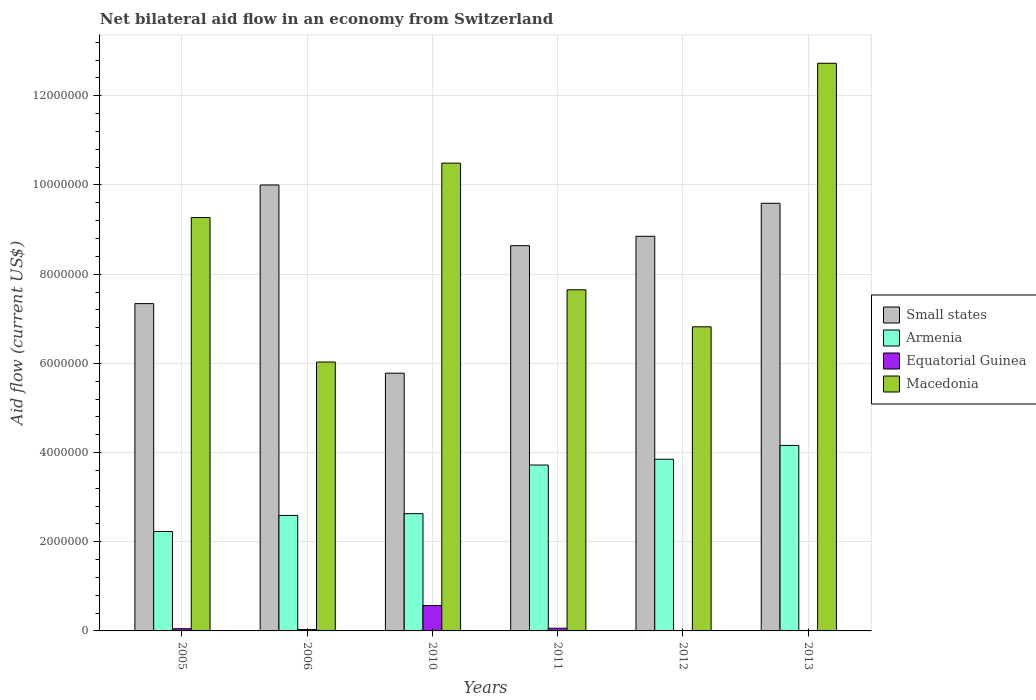How many different coloured bars are there?
Your answer should be very brief. 4. How many groups of bars are there?
Your response must be concise. 6. Are the number of bars on each tick of the X-axis equal?
Give a very brief answer. Yes. What is the label of the 5th group of bars from the left?
Provide a short and direct response. 2012. In how many cases, is the number of bars for a given year not equal to the number of legend labels?
Give a very brief answer. 0. What is the net bilateral aid flow in Armenia in 2010?
Your response must be concise. 2.63e+06. Across all years, what is the maximum net bilateral aid flow in Armenia?
Your response must be concise. 4.16e+06. Across all years, what is the minimum net bilateral aid flow in Equatorial Guinea?
Give a very brief answer. 10000. In which year was the net bilateral aid flow in Small states maximum?
Keep it short and to the point. 2006. What is the total net bilateral aid flow in Macedonia in the graph?
Your answer should be compact. 5.30e+07. What is the difference between the net bilateral aid flow in Small states in 2012 and the net bilateral aid flow in Macedonia in 2006?
Provide a succinct answer. 2.82e+06. What is the average net bilateral aid flow in Armenia per year?
Ensure brevity in your answer.  3.20e+06. In the year 2010, what is the difference between the net bilateral aid flow in Small states and net bilateral aid flow in Armenia?
Give a very brief answer. 3.15e+06. In how many years, is the net bilateral aid flow in Equatorial Guinea greater than 1200000 US$?
Ensure brevity in your answer.  0. What is the ratio of the net bilateral aid flow in Equatorial Guinea in 2005 to that in 2010?
Your response must be concise. 0.09. Is the difference between the net bilateral aid flow in Small states in 2011 and 2012 greater than the difference between the net bilateral aid flow in Armenia in 2011 and 2012?
Provide a short and direct response. No. What is the difference between the highest and the second highest net bilateral aid flow in Armenia?
Offer a terse response. 3.10e+05. What is the difference between the highest and the lowest net bilateral aid flow in Small states?
Your answer should be very brief. 4.22e+06. Is the sum of the net bilateral aid flow in Macedonia in 2011 and 2013 greater than the maximum net bilateral aid flow in Armenia across all years?
Provide a succinct answer. Yes. What does the 3rd bar from the left in 2005 represents?
Give a very brief answer. Equatorial Guinea. What does the 3rd bar from the right in 2005 represents?
Provide a short and direct response. Armenia. Is it the case that in every year, the sum of the net bilateral aid flow in Equatorial Guinea and net bilateral aid flow in Small states is greater than the net bilateral aid flow in Armenia?
Your answer should be very brief. Yes. How many bars are there?
Provide a short and direct response. 24. What is the difference between two consecutive major ticks on the Y-axis?
Give a very brief answer. 2.00e+06. Are the values on the major ticks of Y-axis written in scientific E-notation?
Your answer should be compact. No. Does the graph contain any zero values?
Offer a very short reply. No. Does the graph contain grids?
Provide a short and direct response. Yes. Where does the legend appear in the graph?
Provide a short and direct response. Center right. What is the title of the graph?
Ensure brevity in your answer.  Net bilateral aid flow in an economy from Switzerland. Does "Hungary" appear as one of the legend labels in the graph?
Your response must be concise. No. What is the label or title of the X-axis?
Make the answer very short. Years. What is the label or title of the Y-axis?
Your answer should be compact. Aid flow (current US$). What is the Aid flow (current US$) of Small states in 2005?
Your answer should be compact. 7.34e+06. What is the Aid flow (current US$) in Armenia in 2005?
Your answer should be compact. 2.23e+06. What is the Aid flow (current US$) in Macedonia in 2005?
Your answer should be compact. 9.27e+06. What is the Aid flow (current US$) of Armenia in 2006?
Provide a short and direct response. 2.59e+06. What is the Aid flow (current US$) in Macedonia in 2006?
Offer a terse response. 6.03e+06. What is the Aid flow (current US$) of Small states in 2010?
Give a very brief answer. 5.78e+06. What is the Aid flow (current US$) in Armenia in 2010?
Your answer should be very brief. 2.63e+06. What is the Aid flow (current US$) in Equatorial Guinea in 2010?
Offer a terse response. 5.70e+05. What is the Aid flow (current US$) in Macedonia in 2010?
Keep it short and to the point. 1.05e+07. What is the Aid flow (current US$) in Small states in 2011?
Your answer should be very brief. 8.64e+06. What is the Aid flow (current US$) in Armenia in 2011?
Keep it short and to the point. 3.72e+06. What is the Aid flow (current US$) in Macedonia in 2011?
Provide a short and direct response. 7.65e+06. What is the Aid flow (current US$) of Small states in 2012?
Keep it short and to the point. 8.85e+06. What is the Aid flow (current US$) in Armenia in 2012?
Offer a terse response. 3.85e+06. What is the Aid flow (current US$) in Macedonia in 2012?
Offer a terse response. 6.82e+06. What is the Aid flow (current US$) of Small states in 2013?
Provide a succinct answer. 9.59e+06. What is the Aid flow (current US$) of Armenia in 2013?
Provide a short and direct response. 4.16e+06. What is the Aid flow (current US$) of Macedonia in 2013?
Offer a terse response. 1.27e+07. Across all years, what is the maximum Aid flow (current US$) in Small states?
Offer a terse response. 1.00e+07. Across all years, what is the maximum Aid flow (current US$) in Armenia?
Give a very brief answer. 4.16e+06. Across all years, what is the maximum Aid flow (current US$) in Equatorial Guinea?
Your response must be concise. 5.70e+05. Across all years, what is the maximum Aid flow (current US$) in Macedonia?
Your answer should be compact. 1.27e+07. Across all years, what is the minimum Aid flow (current US$) in Small states?
Provide a succinct answer. 5.78e+06. Across all years, what is the minimum Aid flow (current US$) in Armenia?
Keep it short and to the point. 2.23e+06. Across all years, what is the minimum Aid flow (current US$) in Macedonia?
Your answer should be compact. 6.03e+06. What is the total Aid flow (current US$) of Small states in the graph?
Keep it short and to the point. 5.02e+07. What is the total Aid flow (current US$) of Armenia in the graph?
Offer a terse response. 1.92e+07. What is the total Aid flow (current US$) in Equatorial Guinea in the graph?
Provide a succinct answer. 7.30e+05. What is the total Aid flow (current US$) in Macedonia in the graph?
Offer a terse response. 5.30e+07. What is the difference between the Aid flow (current US$) in Small states in 2005 and that in 2006?
Your answer should be very brief. -2.66e+06. What is the difference between the Aid flow (current US$) in Armenia in 2005 and that in 2006?
Your answer should be compact. -3.60e+05. What is the difference between the Aid flow (current US$) in Equatorial Guinea in 2005 and that in 2006?
Offer a terse response. 2.00e+04. What is the difference between the Aid flow (current US$) in Macedonia in 2005 and that in 2006?
Offer a very short reply. 3.24e+06. What is the difference between the Aid flow (current US$) of Small states in 2005 and that in 2010?
Offer a very short reply. 1.56e+06. What is the difference between the Aid flow (current US$) of Armenia in 2005 and that in 2010?
Keep it short and to the point. -4.00e+05. What is the difference between the Aid flow (current US$) of Equatorial Guinea in 2005 and that in 2010?
Keep it short and to the point. -5.20e+05. What is the difference between the Aid flow (current US$) of Macedonia in 2005 and that in 2010?
Your answer should be compact. -1.22e+06. What is the difference between the Aid flow (current US$) in Small states in 2005 and that in 2011?
Offer a terse response. -1.30e+06. What is the difference between the Aid flow (current US$) in Armenia in 2005 and that in 2011?
Make the answer very short. -1.49e+06. What is the difference between the Aid flow (current US$) of Equatorial Guinea in 2005 and that in 2011?
Offer a terse response. -10000. What is the difference between the Aid flow (current US$) of Macedonia in 2005 and that in 2011?
Make the answer very short. 1.62e+06. What is the difference between the Aid flow (current US$) of Small states in 2005 and that in 2012?
Offer a very short reply. -1.51e+06. What is the difference between the Aid flow (current US$) of Armenia in 2005 and that in 2012?
Provide a succinct answer. -1.62e+06. What is the difference between the Aid flow (current US$) of Equatorial Guinea in 2005 and that in 2012?
Ensure brevity in your answer.  4.00e+04. What is the difference between the Aid flow (current US$) of Macedonia in 2005 and that in 2012?
Provide a succinct answer. 2.45e+06. What is the difference between the Aid flow (current US$) of Small states in 2005 and that in 2013?
Give a very brief answer. -2.25e+06. What is the difference between the Aid flow (current US$) of Armenia in 2005 and that in 2013?
Ensure brevity in your answer.  -1.93e+06. What is the difference between the Aid flow (current US$) in Equatorial Guinea in 2005 and that in 2013?
Keep it short and to the point. 4.00e+04. What is the difference between the Aid flow (current US$) of Macedonia in 2005 and that in 2013?
Your answer should be very brief. -3.46e+06. What is the difference between the Aid flow (current US$) in Small states in 2006 and that in 2010?
Keep it short and to the point. 4.22e+06. What is the difference between the Aid flow (current US$) of Armenia in 2006 and that in 2010?
Offer a terse response. -4.00e+04. What is the difference between the Aid flow (current US$) of Equatorial Guinea in 2006 and that in 2010?
Give a very brief answer. -5.40e+05. What is the difference between the Aid flow (current US$) in Macedonia in 2006 and that in 2010?
Provide a succinct answer. -4.46e+06. What is the difference between the Aid flow (current US$) in Small states in 2006 and that in 2011?
Ensure brevity in your answer.  1.36e+06. What is the difference between the Aid flow (current US$) in Armenia in 2006 and that in 2011?
Your answer should be compact. -1.13e+06. What is the difference between the Aid flow (current US$) in Equatorial Guinea in 2006 and that in 2011?
Make the answer very short. -3.00e+04. What is the difference between the Aid flow (current US$) of Macedonia in 2006 and that in 2011?
Offer a terse response. -1.62e+06. What is the difference between the Aid flow (current US$) of Small states in 2006 and that in 2012?
Make the answer very short. 1.15e+06. What is the difference between the Aid flow (current US$) of Armenia in 2006 and that in 2012?
Your response must be concise. -1.26e+06. What is the difference between the Aid flow (current US$) in Macedonia in 2006 and that in 2012?
Your response must be concise. -7.90e+05. What is the difference between the Aid flow (current US$) in Armenia in 2006 and that in 2013?
Keep it short and to the point. -1.57e+06. What is the difference between the Aid flow (current US$) in Equatorial Guinea in 2006 and that in 2013?
Keep it short and to the point. 2.00e+04. What is the difference between the Aid flow (current US$) in Macedonia in 2006 and that in 2013?
Give a very brief answer. -6.70e+06. What is the difference between the Aid flow (current US$) of Small states in 2010 and that in 2011?
Your response must be concise. -2.86e+06. What is the difference between the Aid flow (current US$) of Armenia in 2010 and that in 2011?
Your response must be concise. -1.09e+06. What is the difference between the Aid flow (current US$) of Equatorial Guinea in 2010 and that in 2011?
Give a very brief answer. 5.10e+05. What is the difference between the Aid flow (current US$) in Macedonia in 2010 and that in 2011?
Provide a succinct answer. 2.84e+06. What is the difference between the Aid flow (current US$) in Small states in 2010 and that in 2012?
Offer a terse response. -3.07e+06. What is the difference between the Aid flow (current US$) of Armenia in 2010 and that in 2012?
Provide a succinct answer. -1.22e+06. What is the difference between the Aid flow (current US$) in Equatorial Guinea in 2010 and that in 2012?
Offer a very short reply. 5.60e+05. What is the difference between the Aid flow (current US$) of Macedonia in 2010 and that in 2012?
Your answer should be very brief. 3.67e+06. What is the difference between the Aid flow (current US$) in Small states in 2010 and that in 2013?
Give a very brief answer. -3.81e+06. What is the difference between the Aid flow (current US$) in Armenia in 2010 and that in 2013?
Offer a very short reply. -1.53e+06. What is the difference between the Aid flow (current US$) of Equatorial Guinea in 2010 and that in 2013?
Your answer should be very brief. 5.60e+05. What is the difference between the Aid flow (current US$) in Macedonia in 2010 and that in 2013?
Offer a very short reply. -2.24e+06. What is the difference between the Aid flow (current US$) in Armenia in 2011 and that in 2012?
Give a very brief answer. -1.30e+05. What is the difference between the Aid flow (current US$) in Equatorial Guinea in 2011 and that in 2012?
Make the answer very short. 5.00e+04. What is the difference between the Aid flow (current US$) in Macedonia in 2011 and that in 2012?
Provide a succinct answer. 8.30e+05. What is the difference between the Aid flow (current US$) of Small states in 2011 and that in 2013?
Offer a terse response. -9.50e+05. What is the difference between the Aid flow (current US$) in Armenia in 2011 and that in 2013?
Make the answer very short. -4.40e+05. What is the difference between the Aid flow (current US$) of Macedonia in 2011 and that in 2013?
Offer a very short reply. -5.08e+06. What is the difference between the Aid flow (current US$) in Small states in 2012 and that in 2013?
Your answer should be compact. -7.40e+05. What is the difference between the Aid flow (current US$) in Armenia in 2012 and that in 2013?
Your answer should be very brief. -3.10e+05. What is the difference between the Aid flow (current US$) in Equatorial Guinea in 2012 and that in 2013?
Your answer should be compact. 0. What is the difference between the Aid flow (current US$) in Macedonia in 2012 and that in 2013?
Offer a terse response. -5.91e+06. What is the difference between the Aid flow (current US$) in Small states in 2005 and the Aid flow (current US$) in Armenia in 2006?
Your response must be concise. 4.75e+06. What is the difference between the Aid flow (current US$) of Small states in 2005 and the Aid flow (current US$) of Equatorial Guinea in 2006?
Your response must be concise. 7.31e+06. What is the difference between the Aid flow (current US$) of Small states in 2005 and the Aid flow (current US$) of Macedonia in 2006?
Give a very brief answer. 1.31e+06. What is the difference between the Aid flow (current US$) in Armenia in 2005 and the Aid flow (current US$) in Equatorial Guinea in 2006?
Offer a terse response. 2.20e+06. What is the difference between the Aid flow (current US$) in Armenia in 2005 and the Aid flow (current US$) in Macedonia in 2006?
Your response must be concise. -3.80e+06. What is the difference between the Aid flow (current US$) in Equatorial Guinea in 2005 and the Aid flow (current US$) in Macedonia in 2006?
Provide a short and direct response. -5.98e+06. What is the difference between the Aid flow (current US$) in Small states in 2005 and the Aid flow (current US$) in Armenia in 2010?
Your answer should be very brief. 4.71e+06. What is the difference between the Aid flow (current US$) in Small states in 2005 and the Aid flow (current US$) in Equatorial Guinea in 2010?
Give a very brief answer. 6.77e+06. What is the difference between the Aid flow (current US$) in Small states in 2005 and the Aid flow (current US$) in Macedonia in 2010?
Keep it short and to the point. -3.15e+06. What is the difference between the Aid flow (current US$) of Armenia in 2005 and the Aid flow (current US$) of Equatorial Guinea in 2010?
Keep it short and to the point. 1.66e+06. What is the difference between the Aid flow (current US$) in Armenia in 2005 and the Aid flow (current US$) in Macedonia in 2010?
Your answer should be very brief. -8.26e+06. What is the difference between the Aid flow (current US$) of Equatorial Guinea in 2005 and the Aid flow (current US$) of Macedonia in 2010?
Provide a succinct answer. -1.04e+07. What is the difference between the Aid flow (current US$) of Small states in 2005 and the Aid flow (current US$) of Armenia in 2011?
Your answer should be compact. 3.62e+06. What is the difference between the Aid flow (current US$) in Small states in 2005 and the Aid flow (current US$) in Equatorial Guinea in 2011?
Provide a short and direct response. 7.28e+06. What is the difference between the Aid flow (current US$) in Small states in 2005 and the Aid flow (current US$) in Macedonia in 2011?
Keep it short and to the point. -3.10e+05. What is the difference between the Aid flow (current US$) of Armenia in 2005 and the Aid flow (current US$) of Equatorial Guinea in 2011?
Give a very brief answer. 2.17e+06. What is the difference between the Aid flow (current US$) in Armenia in 2005 and the Aid flow (current US$) in Macedonia in 2011?
Give a very brief answer. -5.42e+06. What is the difference between the Aid flow (current US$) in Equatorial Guinea in 2005 and the Aid flow (current US$) in Macedonia in 2011?
Provide a succinct answer. -7.60e+06. What is the difference between the Aid flow (current US$) of Small states in 2005 and the Aid flow (current US$) of Armenia in 2012?
Provide a short and direct response. 3.49e+06. What is the difference between the Aid flow (current US$) in Small states in 2005 and the Aid flow (current US$) in Equatorial Guinea in 2012?
Ensure brevity in your answer.  7.33e+06. What is the difference between the Aid flow (current US$) of Small states in 2005 and the Aid flow (current US$) of Macedonia in 2012?
Your answer should be compact. 5.20e+05. What is the difference between the Aid flow (current US$) in Armenia in 2005 and the Aid flow (current US$) in Equatorial Guinea in 2012?
Offer a very short reply. 2.22e+06. What is the difference between the Aid flow (current US$) of Armenia in 2005 and the Aid flow (current US$) of Macedonia in 2012?
Offer a terse response. -4.59e+06. What is the difference between the Aid flow (current US$) of Equatorial Guinea in 2005 and the Aid flow (current US$) of Macedonia in 2012?
Keep it short and to the point. -6.77e+06. What is the difference between the Aid flow (current US$) of Small states in 2005 and the Aid flow (current US$) of Armenia in 2013?
Your answer should be very brief. 3.18e+06. What is the difference between the Aid flow (current US$) of Small states in 2005 and the Aid flow (current US$) of Equatorial Guinea in 2013?
Provide a succinct answer. 7.33e+06. What is the difference between the Aid flow (current US$) of Small states in 2005 and the Aid flow (current US$) of Macedonia in 2013?
Your response must be concise. -5.39e+06. What is the difference between the Aid flow (current US$) in Armenia in 2005 and the Aid flow (current US$) in Equatorial Guinea in 2013?
Your answer should be very brief. 2.22e+06. What is the difference between the Aid flow (current US$) of Armenia in 2005 and the Aid flow (current US$) of Macedonia in 2013?
Provide a short and direct response. -1.05e+07. What is the difference between the Aid flow (current US$) of Equatorial Guinea in 2005 and the Aid flow (current US$) of Macedonia in 2013?
Give a very brief answer. -1.27e+07. What is the difference between the Aid flow (current US$) in Small states in 2006 and the Aid flow (current US$) in Armenia in 2010?
Your answer should be compact. 7.37e+06. What is the difference between the Aid flow (current US$) in Small states in 2006 and the Aid flow (current US$) in Equatorial Guinea in 2010?
Give a very brief answer. 9.43e+06. What is the difference between the Aid flow (current US$) in Small states in 2006 and the Aid flow (current US$) in Macedonia in 2010?
Your answer should be compact. -4.90e+05. What is the difference between the Aid flow (current US$) in Armenia in 2006 and the Aid flow (current US$) in Equatorial Guinea in 2010?
Provide a short and direct response. 2.02e+06. What is the difference between the Aid flow (current US$) in Armenia in 2006 and the Aid flow (current US$) in Macedonia in 2010?
Provide a short and direct response. -7.90e+06. What is the difference between the Aid flow (current US$) of Equatorial Guinea in 2006 and the Aid flow (current US$) of Macedonia in 2010?
Ensure brevity in your answer.  -1.05e+07. What is the difference between the Aid flow (current US$) of Small states in 2006 and the Aid flow (current US$) of Armenia in 2011?
Ensure brevity in your answer.  6.28e+06. What is the difference between the Aid flow (current US$) of Small states in 2006 and the Aid flow (current US$) of Equatorial Guinea in 2011?
Your response must be concise. 9.94e+06. What is the difference between the Aid flow (current US$) of Small states in 2006 and the Aid flow (current US$) of Macedonia in 2011?
Your response must be concise. 2.35e+06. What is the difference between the Aid flow (current US$) in Armenia in 2006 and the Aid flow (current US$) in Equatorial Guinea in 2011?
Provide a short and direct response. 2.53e+06. What is the difference between the Aid flow (current US$) of Armenia in 2006 and the Aid flow (current US$) of Macedonia in 2011?
Keep it short and to the point. -5.06e+06. What is the difference between the Aid flow (current US$) of Equatorial Guinea in 2006 and the Aid flow (current US$) of Macedonia in 2011?
Provide a succinct answer. -7.62e+06. What is the difference between the Aid flow (current US$) of Small states in 2006 and the Aid flow (current US$) of Armenia in 2012?
Provide a succinct answer. 6.15e+06. What is the difference between the Aid flow (current US$) in Small states in 2006 and the Aid flow (current US$) in Equatorial Guinea in 2012?
Make the answer very short. 9.99e+06. What is the difference between the Aid flow (current US$) of Small states in 2006 and the Aid flow (current US$) of Macedonia in 2012?
Give a very brief answer. 3.18e+06. What is the difference between the Aid flow (current US$) of Armenia in 2006 and the Aid flow (current US$) of Equatorial Guinea in 2012?
Provide a short and direct response. 2.58e+06. What is the difference between the Aid flow (current US$) of Armenia in 2006 and the Aid flow (current US$) of Macedonia in 2012?
Your answer should be very brief. -4.23e+06. What is the difference between the Aid flow (current US$) in Equatorial Guinea in 2006 and the Aid flow (current US$) in Macedonia in 2012?
Provide a succinct answer. -6.79e+06. What is the difference between the Aid flow (current US$) of Small states in 2006 and the Aid flow (current US$) of Armenia in 2013?
Your response must be concise. 5.84e+06. What is the difference between the Aid flow (current US$) in Small states in 2006 and the Aid flow (current US$) in Equatorial Guinea in 2013?
Ensure brevity in your answer.  9.99e+06. What is the difference between the Aid flow (current US$) of Small states in 2006 and the Aid flow (current US$) of Macedonia in 2013?
Your answer should be very brief. -2.73e+06. What is the difference between the Aid flow (current US$) of Armenia in 2006 and the Aid flow (current US$) of Equatorial Guinea in 2013?
Your answer should be very brief. 2.58e+06. What is the difference between the Aid flow (current US$) of Armenia in 2006 and the Aid flow (current US$) of Macedonia in 2013?
Your answer should be compact. -1.01e+07. What is the difference between the Aid flow (current US$) of Equatorial Guinea in 2006 and the Aid flow (current US$) of Macedonia in 2013?
Offer a very short reply. -1.27e+07. What is the difference between the Aid flow (current US$) in Small states in 2010 and the Aid flow (current US$) in Armenia in 2011?
Your answer should be compact. 2.06e+06. What is the difference between the Aid flow (current US$) of Small states in 2010 and the Aid flow (current US$) of Equatorial Guinea in 2011?
Offer a terse response. 5.72e+06. What is the difference between the Aid flow (current US$) in Small states in 2010 and the Aid flow (current US$) in Macedonia in 2011?
Give a very brief answer. -1.87e+06. What is the difference between the Aid flow (current US$) in Armenia in 2010 and the Aid flow (current US$) in Equatorial Guinea in 2011?
Offer a very short reply. 2.57e+06. What is the difference between the Aid flow (current US$) of Armenia in 2010 and the Aid flow (current US$) of Macedonia in 2011?
Your answer should be very brief. -5.02e+06. What is the difference between the Aid flow (current US$) of Equatorial Guinea in 2010 and the Aid flow (current US$) of Macedonia in 2011?
Ensure brevity in your answer.  -7.08e+06. What is the difference between the Aid flow (current US$) of Small states in 2010 and the Aid flow (current US$) of Armenia in 2012?
Offer a very short reply. 1.93e+06. What is the difference between the Aid flow (current US$) of Small states in 2010 and the Aid flow (current US$) of Equatorial Guinea in 2012?
Offer a terse response. 5.77e+06. What is the difference between the Aid flow (current US$) of Small states in 2010 and the Aid flow (current US$) of Macedonia in 2012?
Your answer should be compact. -1.04e+06. What is the difference between the Aid flow (current US$) in Armenia in 2010 and the Aid flow (current US$) in Equatorial Guinea in 2012?
Make the answer very short. 2.62e+06. What is the difference between the Aid flow (current US$) in Armenia in 2010 and the Aid flow (current US$) in Macedonia in 2012?
Offer a terse response. -4.19e+06. What is the difference between the Aid flow (current US$) in Equatorial Guinea in 2010 and the Aid flow (current US$) in Macedonia in 2012?
Give a very brief answer. -6.25e+06. What is the difference between the Aid flow (current US$) of Small states in 2010 and the Aid flow (current US$) of Armenia in 2013?
Ensure brevity in your answer.  1.62e+06. What is the difference between the Aid flow (current US$) of Small states in 2010 and the Aid flow (current US$) of Equatorial Guinea in 2013?
Give a very brief answer. 5.77e+06. What is the difference between the Aid flow (current US$) of Small states in 2010 and the Aid flow (current US$) of Macedonia in 2013?
Your response must be concise. -6.95e+06. What is the difference between the Aid flow (current US$) of Armenia in 2010 and the Aid flow (current US$) of Equatorial Guinea in 2013?
Ensure brevity in your answer.  2.62e+06. What is the difference between the Aid flow (current US$) of Armenia in 2010 and the Aid flow (current US$) of Macedonia in 2013?
Offer a very short reply. -1.01e+07. What is the difference between the Aid flow (current US$) of Equatorial Guinea in 2010 and the Aid flow (current US$) of Macedonia in 2013?
Ensure brevity in your answer.  -1.22e+07. What is the difference between the Aid flow (current US$) of Small states in 2011 and the Aid flow (current US$) of Armenia in 2012?
Provide a short and direct response. 4.79e+06. What is the difference between the Aid flow (current US$) of Small states in 2011 and the Aid flow (current US$) of Equatorial Guinea in 2012?
Keep it short and to the point. 8.63e+06. What is the difference between the Aid flow (current US$) in Small states in 2011 and the Aid flow (current US$) in Macedonia in 2012?
Your answer should be very brief. 1.82e+06. What is the difference between the Aid flow (current US$) of Armenia in 2011 and the Aid flow (current US$) of Equatorial Guinea in 2012?
Your answer should be very brief. 3.71e+06. What is the difference between the Aid flow (current US$) in Armenia in 2011 and the Aid flow (current US$) in Macedonia in 2012?
Provide a short and direct response. -3.10e+06. What is the difference between the Aid flow (current US$) in Equatorial Guinea in 2011 and the Aid flow (current US$) in Macedonia in 2012?
Keep it short and to the point. -6.76e+06. What is the difference between the Aid flow (current US$) of Small states in 2011 and the Aid flow (current US$) of Armenia in 2013?
Your answer should be compact. 4.48e+06. What is the difference between the Aid flow (current US$) in Small states in 2011 and the Aid flow (current US$) in Equatorial Guinea in 2013?
Offer a very short reply. 8.63e+06. What is the difference between the Aid flow (current US$) in Small states in 2011 and the Aid flow (current US$) in Macedonia in 2013?
Your answer should be compact. -4.09e+06. What is the difference between the Aid flow (current US$) in Armenia in 2011 and the Aid flow (current US$) in Equatorial Guinea in 2013?
Provide a succinct answer. 3.71e+06. What is the difference between the Aid flow (current US$) of Armenia in 2011 and the Aid flow (current US$) of Macedonia in 2013?
Your answer should be compact. -9.01e+06. What is the difference between the Aid flow (current US$) in Equatorial Guinea in 2011 and the Aid flow (current US$) in Macedonia in 2013?
Offer a terse response. -1.27e+07. What is the difference between the Aid flow (current US$) of Small states in 2012 and the Aid flow (current US$) of Armenia in 2013?
Provide a short and direct response. 4.69e+06. What is the difference between the Aid flow (current US$) in Small states in 2012 and the Aid flow (current US$) in Equatorial Guinea in 2013?
Your answer should be very brief. 8.84e+06. What is the difference between the Aid flow (current US$) of Small states in 2012 and the Aid flow (current US$) of Macedonia in 2013?
Provide a short and direct response. -3.88e+06. What is the difference between the Aid flow (current US$) in Armenia in 2012 and the Aid flow (current US$) in Equatorial Guinea in 2013?
Your response must be concise. 3.84e+06. What is the difference between the Aid flow (current US$) in Armenia in 2012 and the Aid flow (current US$) in Macedonia in 2013?
Ensure brevity in your answer.  -8.88e+06. What is the difference between the Aid flow (current US$) in Equatorial Guinea in 2012 and the Aid flow (current US$) in Macedonia in 2013?
Give a very brief answer. -1.27e+07. What is the average Aid flow (current US$) in Small states per year?
Offer a terse response. 8.37e+06. What is the average Aid flow (current US$) of Armenia per year?
Keep it short and to the point. 3.20e+06. What is the average Aid flow (current US$) in Equatorial Guinea per year?
Your response must be concise. 1.22e+05. What is the average Aid flow (current US$) in Macedonia per year?
Provide a short and direct response. 8.83e+06. In the year 2005, what is the difference between the Aid flow (current US$) of Small states and Aid flow (current US$) of Armenia?
Your answer should be very brief. 5.11e+06. In the year 2005, what is the difference between the Aid flow (current US$) of Small states and Aid flow (current US$) of Equatorial Guinea?
Your answer should be very brief. 7.29e+06. In the year 2005, what is the difference between the Aid flow (current US$) in Small states and Aid flow (current US$) in Macedonia?
Your answer should be very brief. -1.93e+06. In the year 2005, what is the difference between the Aid flow (current US$) in Armenia and Aid flow (current US$) in Equatorial Guinea?
Your answer should be very brief. 2.18e+06. In the year 2005, what is the difference between the Aid flow (current US$) of Armenia and Aid flow (current US$) of Macedonia?
Give a very brief answer. -7.04e+06. In the year 2005, what is the difference between the Aid flow (current US$) in Equatorial Guinea and Aid flow (current US$) in Macedonia?
Your response must be concise. -9.22e+06. In the year 2006, what is the difference between the Aid flow (current US$) of Small states and Aid flow (current US$) of Armenia?
Provide a succinct answer. 7.41e+06. In the year 2006, what is the difference between the Aid flow (current US$) of Small states and Aid flow (current US$) of Equatorial Guinea?
Your answer should be compact. 9.97e+06. In the year 2006, what is the difference between the Aid flow (current US$) of Small states and Aid flow (current US$) of Macedonia?
Provide a short and direct response. 3.97e+06. In the year 2006, what is the difference between the Aid flow (current US$) in Armenia and Aid flow (current US$) in Equatorial Guinea?
Your answer should be very brief. 2.56e+06. In the year 2006, what is the difference between the Aid flow (current US$) of Armenia and Aid flow (current US$) of Macedonia?
Give a very brief answer. -3.44e+06. In the year 2006, what is the difference between the Aid flow (current US$) of Equatorial Guinea and Aid flow (current US$) of Macedonia?
Keep it short and to the point. -6.00e+06. In the year 2010, what is the difference between the Aid flow (current US$) of Small states and Aid flow (current US$) of Armenia?
Keep it short and to the point. 3.15e+06. In the year 2010, what is the difference between the Aid flow (current US$) in Small states and Aid flow (current US$) in Equatorial Guinea?
Make the answer very short. 5.21e+06. In the year 2010, what is the difference between the Aid flow (current US$) in Small states and Aid flow (current US$) in Macedonia?
Your answer should be very brief. -4.71e+06. In the year 2010, what is the difference between the Aid flow (current US$) of Armenia and Aid flow (current US$) of Equatorial Guinea?
Ensure brevity in your answer.  2.06e+06. In the year 2010, what is the difference between the Aid flow (current US$) in Armenia and Aid flow (current US$) in Macedonia?
Keep it short and to the point. -7.86e+06. In the year 2010, what is the difference between the Aid flow (current US$) in Equatorial Guinea and Aid flow (current US$) in Macedonia?
Offer a very short reply. -9.92e+06. In the year 2011, what is the difference between the Aid flow (current US$) in Small states and Aid flow (current US$) in Armenia?
Give a very brief answer. 4.92e+06. In the year 2011, what is the difference between the Aid flow (current US$) of Small states and Aid flow (current US$) of Equatorial Guinea?
Offer a terse response. 8.58e+06. In the year 2011, what is the difference between the Aid flow (current US$) in Small states and Aid flow (current US$) in Macedonia?
Make the answer very short. 9.90e+05. In the year 2011, what is the difference between the Aid flow (current US$) of Armenia and Aid flow (current US$) of Equatorial Guinea?
Keep it short and to the point. 3.66e+06. In the year 2011, what is the difference between the Aid flow (current US$) of Armenia and Aid flow (current US$) of Macedonia?
Offer a terse response. -3.93e+06. In the year 2011, what is the difference between the Aid flow (current US$) in Equatorial Guinea and Aid flow (current US$) in Macedonia?
Your response must be concise. -7.59e+06. In the year 2012, what is the difference between the Aid flow (current US$) of Small states and Aid flow (current US$) of Armenia?
Your answer should be compact. 5.00e+06. In the year 2012, what is the difference between the Aid flow (current US$) in Small states and Aid flow (current US$) in Equatorial Guinea?
Offer a very short reply. 8.84e+06. In the year 2012, what is the difference between the Aid flow (current US$) of Small states and Aid flow (current US$) of Macedonia?
Ensure brevity in your answer.  2.03e+06. In the year 2012, what is the difference between the Aid flow (current US$) of Armenia and Aid flow (current US$) of Equatorial Guinea?
Provide a short and direct response. 3.84e+06. In the year 2012, what is the difference between the Aid flow (current US$) in Armenia and Aid flow (current US$) in Macedonia?
Your answer should be compact. -2.97e+06. In the year 2012, what is the difference between the Aid flow (current US$) in Equatorial Guinea and Aid flow (current US$) in Macedonia?
Your answer should be very brief. -6.81e+06. In the year 2013, what is the difference between the Aid flow (current US$) in Small states and Aid flow (current US$) in Armenia?
Keep it short and to the point. 5.43e+06. In the year 2013, what is the difference between the Aid flow (current US$) of Small states and Aid flow (current US$) of Equatorial Guinea?
Keep it short and to the point. 9.58e+06. In the year 2013, what is the difference between the Aid flow (current US$) in Small states and Aid flow (current US$) in Macedonia?
Your response must be concise. -3.14e+06. In the year 2013, what is the difference between the Aid flow (current US$) of Armenia and Aid flow (current US$) of Equatorial Guinea?
Keep it short and to the point. 4.15e+06. In the year 2013, what is the difference between the Aid flow (current US$) in Armenia and Aid flow (current US$) in Macedonia?
Keep it short and to the point. -8.57e+06. In the year 2013, what is the difference between the Aid flow (current US$) of Equatorial Guinea and Aid flow (current US$) of Macedonia?
Your answer should be compact. -1.27e+07. What is the ratio of the Aid flow (current US$) in Small states in 2005 to that in 2006?
Offer a very short reply. 0.73. What is the ratio of the Aid flow (current US$) in Armenia in 2005 to that in 2006?
Keep it short and to the point. 0.86. What is the ratio of the Aid flow (current US$) of Macedonia in 2005 to that in 2006?
Keep it short and to the point. 1.54. What is the ratio of the Aid flow (current US$) in Small states in 2005 to that in 2010?
Offer a terse response. 1.27. What is the ratio of the Aid flow (current US$) in Armenia in 2005 to that in 2010?
Provide a short and direct response. 0.85. What is the ratio of the Aid flow (current US$) of Equatorial Guinea in 2005 to that in 2010?
Your answer should be very brief. 0.09. What is the ratio of the Aid flow (current US$) of Macedonia in 2005 to that in 2010?
Give a very brief answer. 0.88. What is the ratio of the Aid flow (current US$) in Small states in 2005 to that in 2011?
Provide a succinct answer. 0.85. What is the ratio of the Aid flow (current US$) in Armenia in 2005 to that in 2011?
Keep it short and to the point. 0.6. What is the ratio of the Aid flow (current US$) of Equatorial Guinea in 2005 to that in 2011?
Your answer should be compact. 0.83. What is the ratio of the Aid flow (current US$) in Macedonia in 2005 to that in 2011?
Provide a succinct answer. 1.21. What is the ratio of the Aid flow (current US$) of Small states in 2005 to that in 2012?
Provide a succinct answer. 0.83. What is the ratio of the Aid flow (current US$) in Armenia in 2005 to that in 2012?
Ensure brevity in your answer.  0.58. What is the ratio of the Aid flow (current US$) in Macedonia in 2005 to that in 2012?
Offer a very short reply. 1.36. What is the ratio of the Aid flow (current US$) in Small states in 2005 to that in 2013?
Your answer should be compact. 0.77. What is the ratio of the Aid flow (current US$) of Armenia in 2005 to that in 2013?
Offer a terse response. 0.54. What is the ratio of the Aid flow (current US$) in Equatorial Guinea in 2005 to that in 2013?
Give a very brief answer. 5. What is the ratio of the Aid flow (current US$) in Macedonia in 2005 to that in 2013?
Provide a short and direct response. 0.73. What is the ratio of the Aid flow (current US$) of Small states in 2006 to that in 2010?
Offer a terse response. 1.73. What is the ratio of the Aid flow (current US$) in Equatorial Guinea in 2006 to that in 2010?
Your answer should be very brief. 0.05. What is the ratio of the Aid flow (current US$) of Macedonia in 2006 to that in 2010?
Provide a short and direct response. 0.57. What is the ratio of the Aid flow (current US$) of Small states in 2006 to that in 2011?
Your answer should be very brief. 1.16. What is the ratio of the Aid flow (current US$) in Armenia in 2006 to that in 2011?
Your answer should be very brief. 0.7. What is the ratio of the Aid flow (current US$) in Equatorial Guinea in 2006 to that in 2011?
Make the answer very short. 0.5. What is the ratio of the Aid flow (current US$) in Macedonia in 2006 to that in 2011?
Offer a terse response. 0.79. What is the ratio of the Aid flow (current US$) of Small states in 2006 to that in 2012?
Provide a short and direct response. 1.13. What is the ratio of the Aid flow (current US$) in Armenia in 2006 to that in 2012?
Your answer should be very brief. 0.67. What is the ratio of the Aid flow (current US$) of Macedonia in 2006 to that in 2012?
Your answer should be very brief. 0.88. What is the ratio of the Aid flow (current US$) of Small states in 2006 to that in 2013?
Ensure brevity in your answer.  1.04. What is the ratio of the Aid flow (current US$) of Armenia in 2006 to that in 2013?
Keep it short and to the point. 0.62. What is the ratio of the Aid flow (current US$) of Equatorial Guinea in 2006 to that in 2013?
Give a very brief answer. 3. What is the ratio of the Aid flow (current US$) of Macedonia in 2006 to that in 2013?
Make the answer very short. 0.47. What is the ratio of the Aid flow (current US$) of Small states in 2010 to that in 2011?
Provide a short and direct response. 0.67. What is the ratio of the Aid flow (current US$) in Armenia in 2010 to that in 2011?
Give a very brief answer. 0.71. What is the ratio of the Aid flow (current US$) in Macedonia in 2010 to that in 2011?
Offer a very short reply. 1.37. What is the ratio of the Aid flow (current US$) in Small states in 2010 to that in 2012?
Offer a very short reply. 0.65. What is the ratio of the Aid flow (current US$) in Armenia in 2010 to that in 2012?
Provide a succinct answer. 0.68. What is the ratio of the Aid flow (current US$) in Macedonia in 2010 to that in 2012?
Keep it short and to the point. 1.54. What is the ratio of the Aid flow (current US$) in Small states in 2010 to that in 2013?
Your answer should be very brief. 0.6. What is the ratio of the Aid flow (current US$) in Armenia in 2010 to that in 2013?
Give a very brief answer. 0.63. What is the ratio of the Aid flow (current US$) in Equatorial Guinea in 2010 to that in 2013?
Give a very brief answer. 57. What is the ratio of the Aid flow (current US$) of Macedonia in 2010 to that in 2013?
Your answer should be very brief. 0.82. What is the ratio of the Aid flow (current US$) in Small states in 2011 to that in 2012?
Make the answer very short. 0.98. What is the ratio of the Aid flow (current US$) of Armenia in 2011 to that in 2012?
Ensure brevity in your answer.  0.97. What is the ratio of the Aid flow (current US$) of Equatorial Guinea in 2011 to that in 2012?
Offer a very short reply. 6. What is the ratio of the Aid flow (current US$) in Macedonia in 2011 to that in 2012?
Keep it short and to the point. 1.12. What is the ratio of the Aid flow (current US$) in Small states in 2011 to that in 2013?
Provide a short and direct response. 0.9. What is the ratio of the Aid flow (current US$) of Armenia in 2011 to that in 2013?
Your response must be concise. 0.89. What is the ratio of the Aid flow (current US$) of Macedonia in 2011 to that in 2013?
Provide a succinct answer. 0.6. What is the ratio of the Aid flow (current US$) of Small states in 2012 to that in 2013?
Ensure brevity in your answer.  0.92. What is the ratio of the Aid flow (current US$) of Armenia in 2012 to that in 2013?
Your response must be concise. 0.93. What is the ratio of the Aid flow (current US$) of Macedonia in 2012 to that in 2013?
Offer a terse response. 0.54. What is the difference between the highest and the second highest Aid flow (current US$) in Small states?
Give a very brief answer. 4.10e+05. What is the difference between the highest and the second highest Aid flow (current US$) in Armenia?
Your answer should be very brief. 3.10e+05. What is the difference between the highest and the second highest Aid flow (current US$) in Equatorial Guinea?
Keep it short and to the point. 5.10e+05. What is the difference between the highest and the second highest Aid flow (current US$) in Macedonia?
Offer a very short reply. 2.24e+06. What is the difference between the highest and the lowest Aid flow (current US$) in Small states?
Your answer should be compact. 4.22e+06. What is the difference between the highest and the lowest Aid flow (current US$) in Armenia?
Ensure brevity in your answer.  1.93e+06. What is the difference between the highest and the lowest Aid flow (current US$) in Equatorial Guinea?
Provide a short and direct response. 5.60e+05. What is the difference between the highest and the lowest Aid flow (current US$) of Macedonia?
Provide a succinct answer. 6.70e+06. 